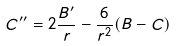Convert formula to latex. <formula><loc_0><loc_0><loc_500><loc_500>C ^ { \prime \prime } = 2 \frac { B ^ { \prime } } { r } - \frac { 6 } { r ^ { 2 } } ( B - C )</formula> 